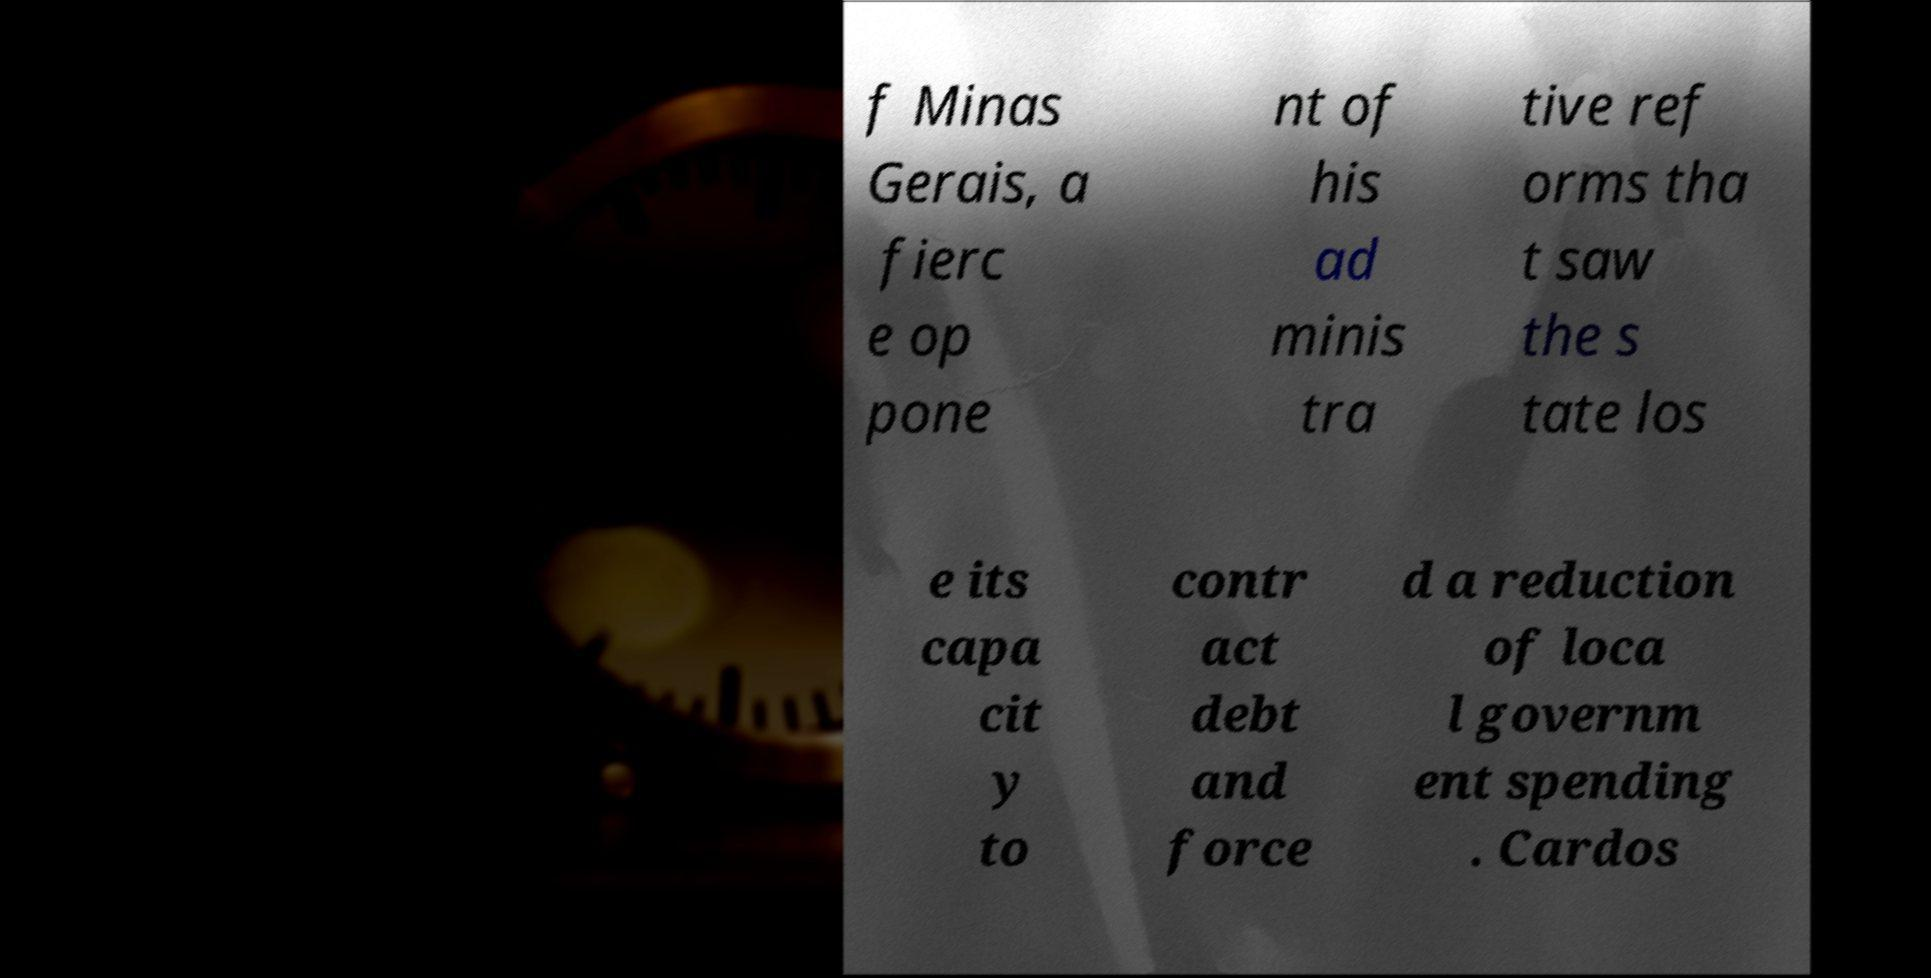Can you accurately transcribe the text from the provided image for me? f Minas Gerais, a fierc e op pone nt of his ad minis tra tive ref orms tha t saw the s tate los e its capa cit y to contr act debt and force d a reduction of loca l governm ent spending . Cardos 